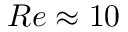<formula> <loc_0><loc_0><loc_500><loc_500>R e \approx 1 0</formula> 